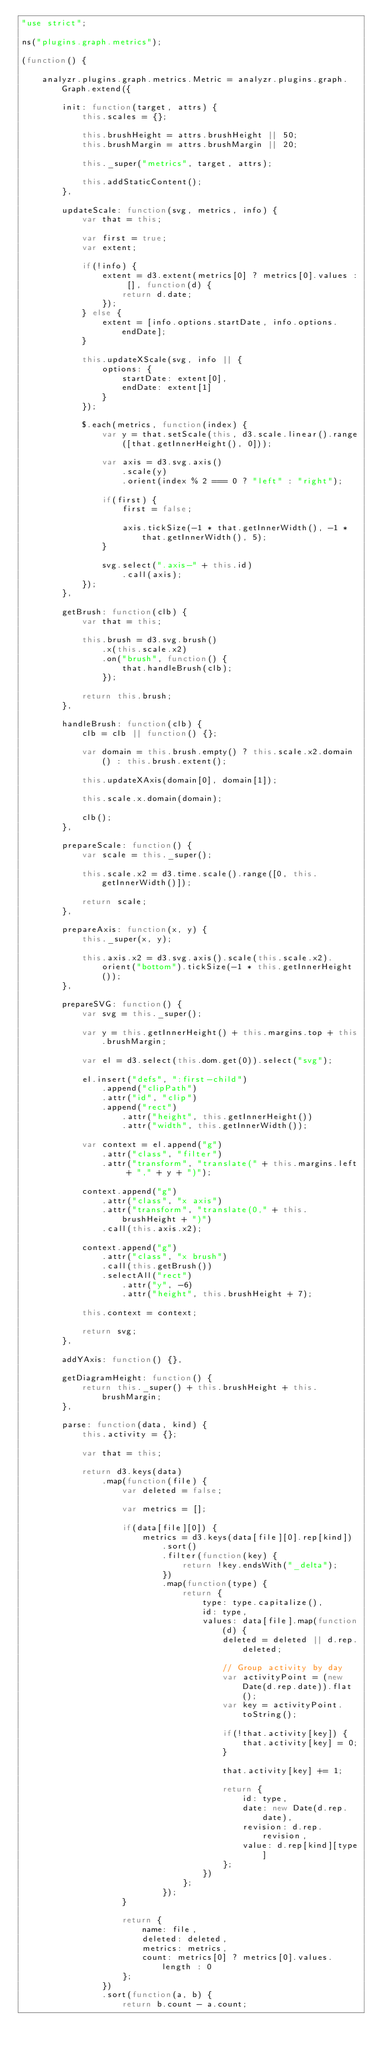Convert code to text. <code><loc_0><loc_0><loc_500><loc_500><_JavaScript_>"use strict";

ns("plugins.graph.metrics");

(function() {

    analyzr.plugins.graph.metrics.Metric = analyzr.plugins.graph.Graph.extend({

        init: function(target, attrs) {
            this.scales = {};

            this.brushHeight = attrs.brushHeight || 50;
            this.brushMargin = attrs.brushMargin || 20;

            this._super("metrics", target, attrs);

            this.addStaticContent();
        },

        updateScale: function(svg, metrics, info) {
            var that = this;

            var first = true;
            var extent;

            if(!info) {
                extent = d3.extent(metrics[0] ? metrics[0].values : [], function(d) {
                    return d.date;
                });
            } else {
                extent = [info.options.startDate, info.options.endDate];
            }

            this.updateXScale(svg, info || {
                options: {
                    startDate: extent[0],
                    endDate: extent[1]
                }
            });

            $.each(metrics, function(index) {
                var y = that.setScale(this, d3.scale.linear().range([that.getInnerHeight(), 0]));

                var axis = d3.svg.axis()
                    .scale(y)
                    .orient(index % 2 === 0 ? "left" : "right");

                if(first) {
                    first = false;

                    axis.tickSize(-1 * that.getInnerWidth(), -1 * that.getInnerWidth(), 5);
                }

                svg.select(".axis-" + this.id)
                    .call(axis);
            });
        },

        getBrush: function(clb) {
            var that = this;

            this.brush = d3.svg.brush()
                .x(this.scale.x2)
                .on("brush", function() {
                    that.handleBrush(clb);
                });

            return this.brush;
        },

        handleBrush: function(clb) {
            clb = clb || function() {};

            var domain = this.brush.empty() ? this.scale.x2.domain() : this.brush.extent();

            this.updateXAxis(domain[0], domain[1]);

            this.scale.x.domain(domain);

            clb();
        },

        prepareScale: function() {
            var scale = this._super();

            this.scale.x2 = d3.time.scale().range([0, this.getInnerWidth()]);

            return scale;
        },

        prepareAxis: function(x, y) {
            this._super(x, y);

            this.axis.x2 = d3.svg.axis().scale(this.scale.x2).orient("bottom").tickSize(-1 * this.getInnerHeight());
        },

        prepareSVG: function() {
            var svg = this._super();

            var y = this.getInnerHeight() + this.margins.top + this.brushMargin;

            var el = d3.select(this.dom.get(0)).select("svg");

            el.insert("defs", ":first-child")
                .append("clipPath")
                .attr("id", "clip")
                .append("rect")
                    .attr("height", this.getInnerHeight())
                    .attr("width", this.getInnerWidth());

            var context = el.append("g")
                .attr("class", "filter")
                .attr("transform", "translate(" + this.margins.left + "," + y + ")");

            context.append("g")
                .attr("class", "x axis")
                .attr("transform", "translate(0," + this.brushHeight + ")")
                .call(this.axis.x2);

            context.append("g")
                .attr("class", "x brush")
                .call(this.getBrush())
                .selectAll("rect")
                    .attr("y", -6)
                    .attr("height", this.brushHeight + 7);

            this.context = context;

            return svg;
        },

        addYAxis: function() {},

        getDiagramHeight: function() {
            return this._super() + this.brushHeight + this.brushMargin;
        },

        parse: function(data, kind) {
            this.activity = {};

            var that = this;

            return d3.keys(data)
                .map(function(file) {
                    var deleted = false;

                    var metrics = [];

                    if(data[file][0]) {
                        metrics = d3.keys(data[file][0].rep[kind])
                            .sort()
                            .filter(function(key) {
                                return !key.endsWith("_delta");
                            })
                            .map(function(type) {
                                return {
                                    type: type.capitalize(),
                                    id: type,
                                    values: data[file].map(function(d) {
                                        deleted = deleted || d.rep.deleted;

                                        // Group activity by day
                                        var activityPoint = (new Date(d.rep.date)).flat();
                                        var key = activityPoint.toString();

                                        if(!that.activity[key]) {
                                            that.activity[key] = 0;
                                        }

                                        that.activity[key] += 1;

                                        return {
                                            id: type,
                                            date: new Date(d.rep.date),
                                            revision: d.rep.revision,
                                            value: d.rep[kind][type]
                                        };
                                    })
                                };
                            });
                    }

                    return {
                        name: file,
                        deleted: deleted,
                        metrics: metrics,
                        count: metrics[0] ? metrics[0].values.length : 0
                    };
                })
                .sort(function(a, b) {
                    return b.count - a.count;</code> 